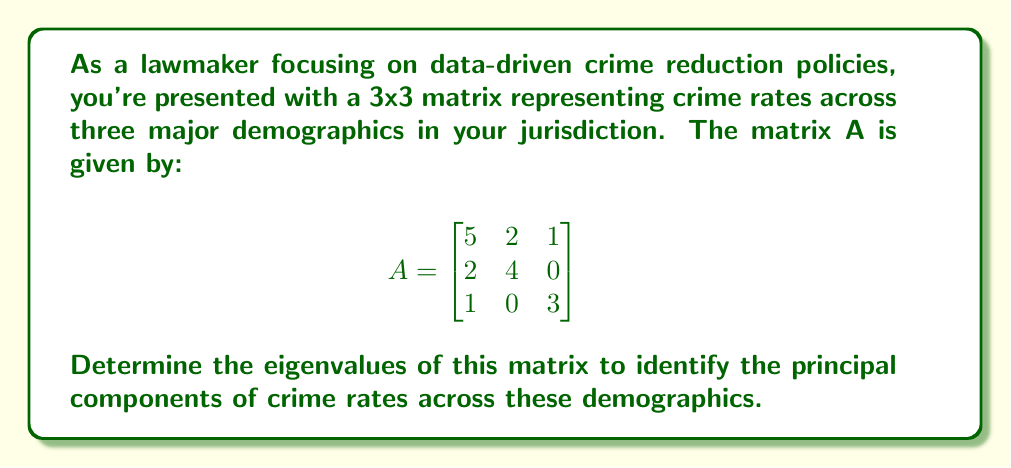Give your solution to this math problem. To find the eigenvalues of matrix A, we need to solve the characteristic equation:

1) First, we set up the equation $det(A - \lambda I) = 0$, where $\lambda$ represents the eigenvalues and I is the 3x3 identity matrix:

   $$det\begin{pmatrix}
   5-\lambda & 2 & 1 \\
   2 & 4-\lambda & 0 \\
   1 & 0 & 3-\lambda
   \end{pmatrix} = 0$$

2) Expand the determinant:
   $$(5-\lambda)[(4-\lambda)(3-\lambda) - 0] - 2[2(3-\lambda) - 0] + 1[2\cdot0 - 1(4-\lambda)] = 0$$

3) Simplify:
   $$(5-\lambda)(12-7\lambda+\lambda^2) - 2(6-2\lambda) + (λ-4) = 0$$
   
4) Expand further:
   $$60-35\lambda+5\lambda^2-12\lambda+7\lambda^2-\lambda^3 - 12+4\lambda + \lambda-4 = 0$$

5) Collect like terms:
   $$-\lambda^3 + 12\lambda^2 - 42\lambda + 44 = 0$$

6) This is a cubic equation. We can factor out $(\lambda - 2)$:
   $$(\lambda - 2)(-\lambda^2 + 10\lambda - 22) = 0$$

7) Using the quadratic formula on $-\lambda^2 + 10\lambda - 22 = 0$, we get:
   $$\lambda = \frac{10 \pm \sqrt{100 - 4(-1)(-22)}}{2(-1)} = \frac{10 \pm \sqrt{12}}{-2} = 5 \pm \sqrt{3}$$

Therefore, the eigenvalues are $\lambda_1 = 2$, $\lambda_2 = 5 + \sqrt{3}$, and $\lambda_3 = 5 - \sqrt{3}$.
Answer: $2$, $5 + \sqrt{3}$, $5 - \sqrt{3}$ 